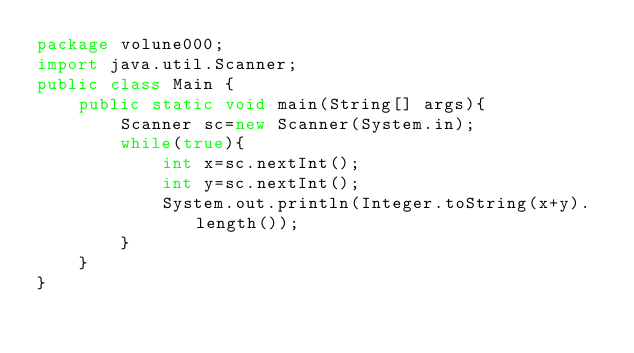Convert code to text. <code><loc_0><loc_0><loc_500><loc_500><_Java_>package volune000;
import java.util.Scanner;
public class Main {
	public static void main(String[] args){
		Scanner sc=new Scanner(System.in);
		while(true){
			int x=sc.nextInt();
			int y=sc.nextInt();
			System.out.println(Integer.toString(x+y).length());
		}
	}
}</code> 